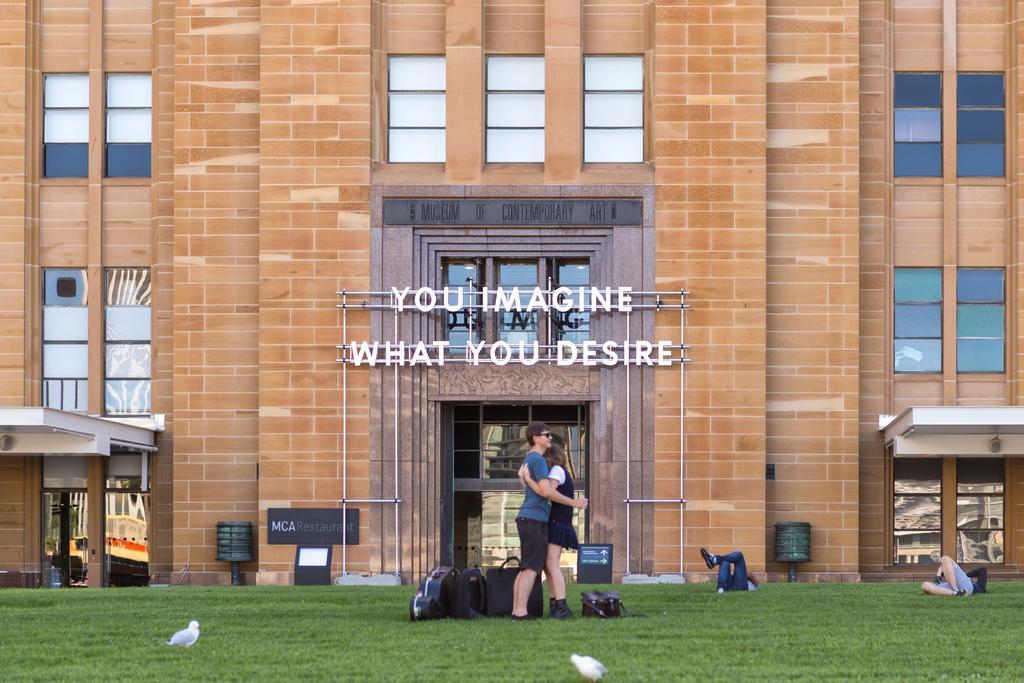Could you give a brief overview of what you see in this image? This image consists of a building along with windows and a door. And we can see the text on a stand. At the bottom, there is green grass. And we can see two birds. In the front, there is a man and a woman hugging. And we can see many bags in this image. 